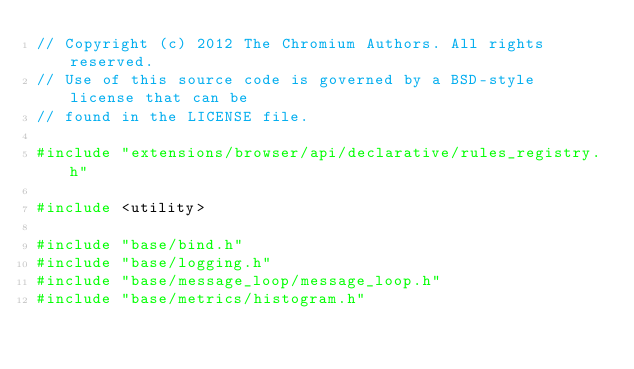<code> <loc_0><loc_0><loc_500><loc_500><_C++_>// Copyright (c) 2012 The Chromium Authors. All rights reserved.
// Use of this source code is governed by a BSD-style license that can be
// found in the LICENSE file.

#include "extensions/browser/api/declarative/rules_registry.h"

#include <utility>

#include "base/bind.h"
#include "base/logging.h"
#include "base/message_loop/message_loop.h"
#include "base/metrics/histogram.h"</code> 